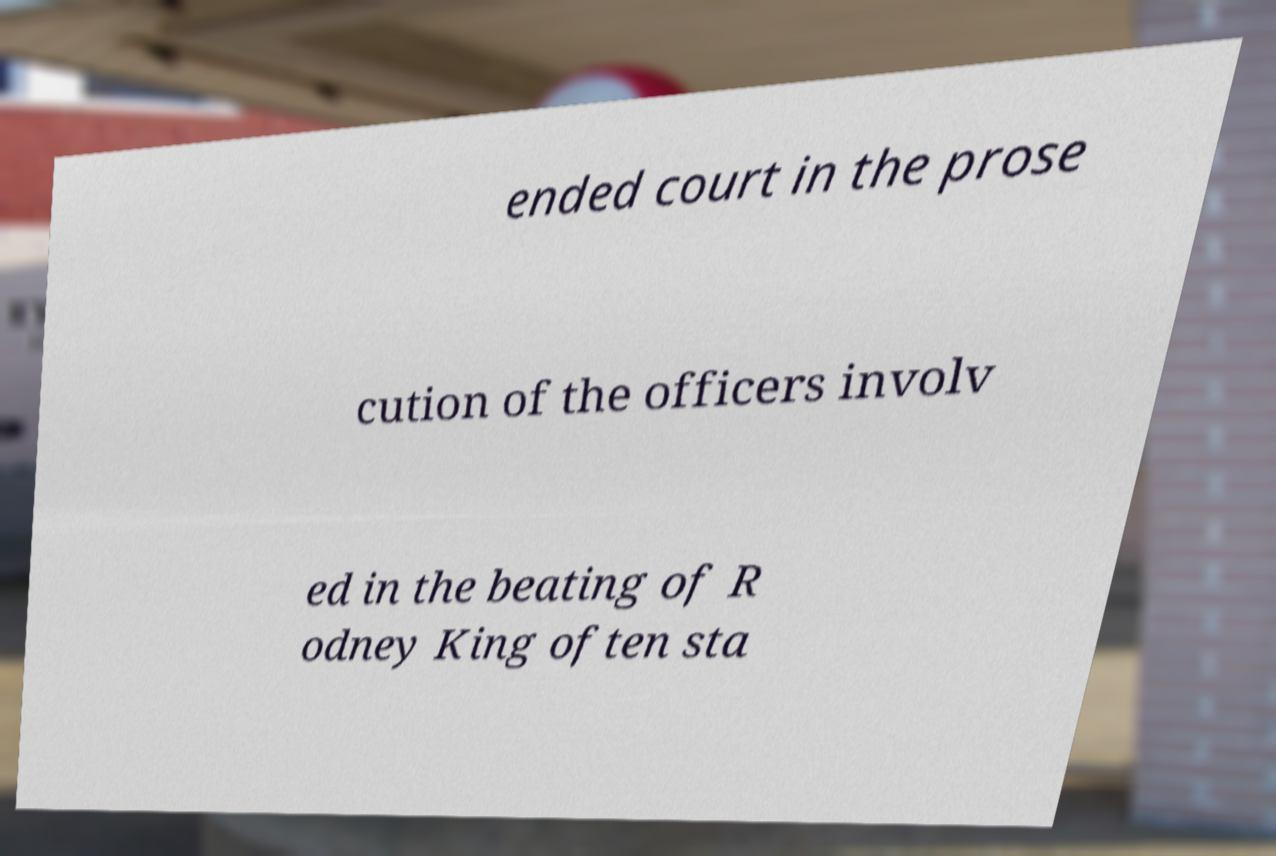Can you read and provide the text displayed in the image?This photo seems to have some interesting text. Can you extract and type it out for me? ended court in the prose cution of the officers involv ed in the beating of R odney King often sta 